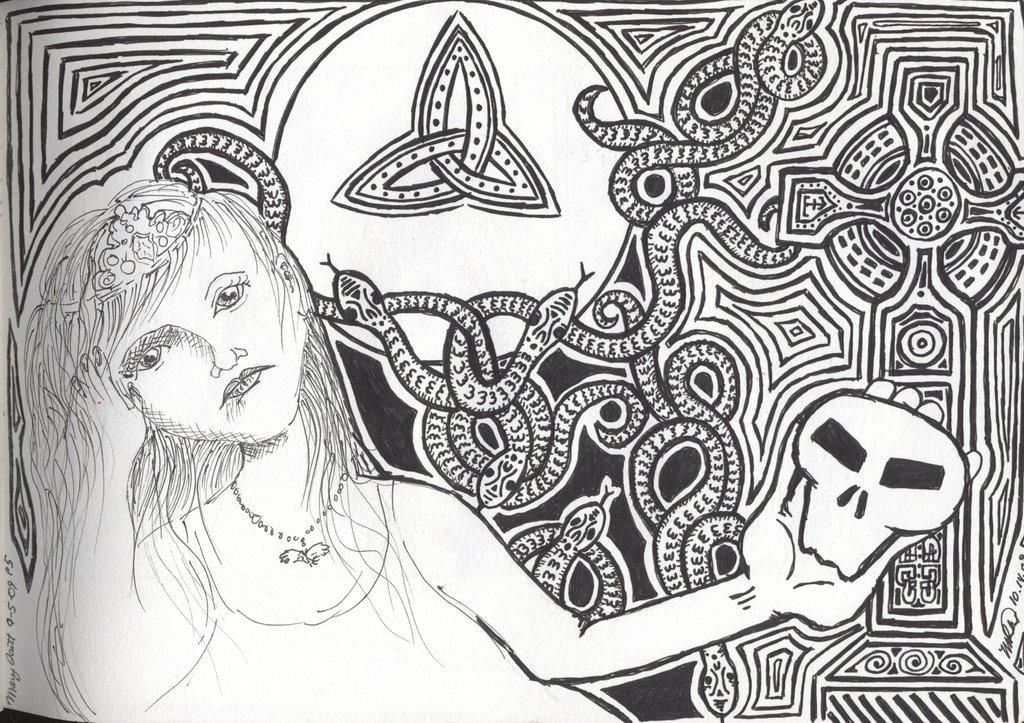What is the main subject of the image? The image depicts a piece of art. What does the art appear to represent? The art appears to represent a woman. Are there any specific design elements on the woman's body in the art? Yes, there are snakes in the design on the back of the woman. What type of song is being sung by the flower in the image? There is no flower or song present in the image; it features a piece of art representing a woman with snakes in the design on her back. 